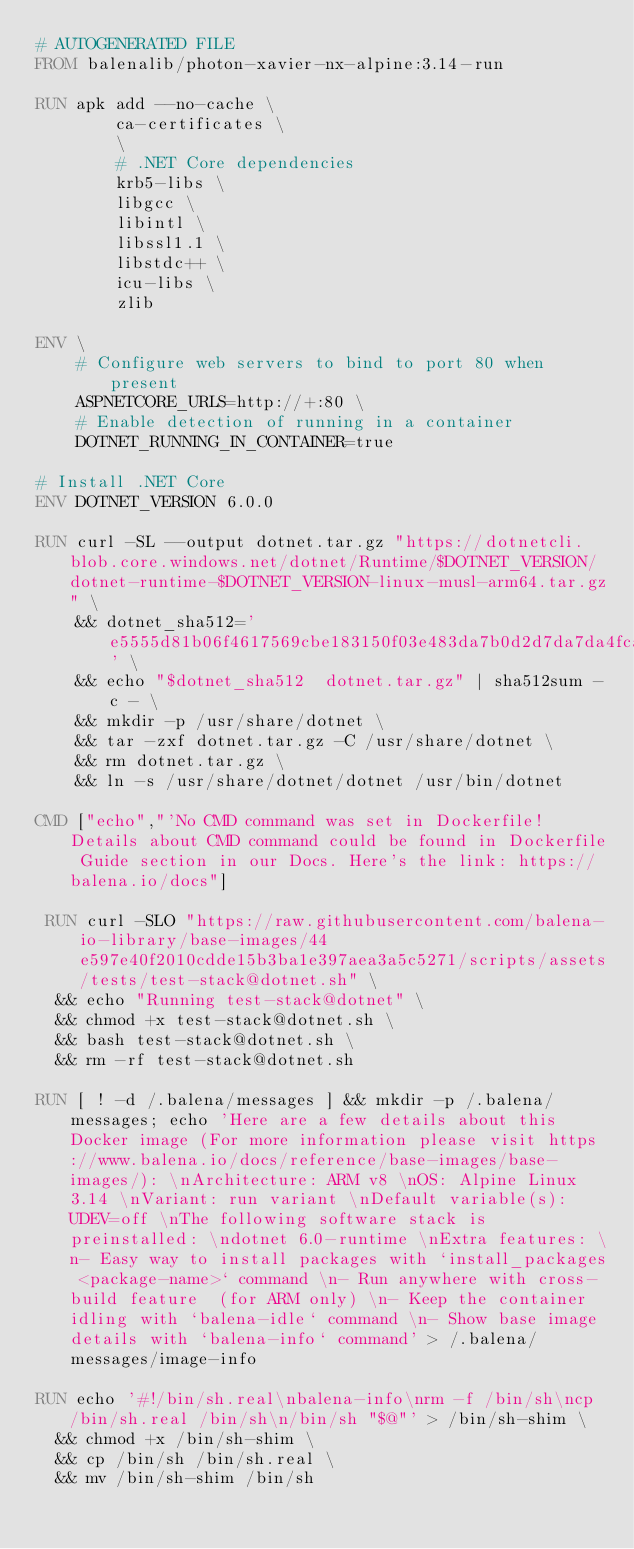<code> <loc_0><loc_0><loc_500><loc_500><_Dockerfile_># AUTOGENERATED FILE
FROM balenalib/photon-xavier-nx-alpine:3.14-run

RUN apk add --no-cache \
        ca-certificates \
        \
        # .NET Core dependencies
        krb5-libs \
        libgcc \
        libintl \
        libssl1.1 \
        libstdc++ \
        icu-libs \
        zlib

ENV \
    # Configure web servers to bind to port 80 when present
    ASPNETCORE_URLS=http://+:80 \
    # Enable detection of running in a container
    DOTNET_RUNNING_IN_CONTAINER=true

# Install .NET Core
ENV DOTNET_VERSION 6.0.0

RUN curl -SL --output dotnet.tar.gz "https://dotnetcli.blob.core.windows.net/dotnet/Runtime/$DOTNET_VERSION/dotnet-runtime-$DOTNET_VERSION-linux-musl-arm64.tar.gz" \
    && dotnet_sha512='e5555d81b06f4617569cbe183150f03e483da7b0d2d7da7da4fcaa80decd1ae2369efc4122eb3c6e59a0631c6a51559d8458a022680074f2548df534685ff2cb' \
    && echo "$dotnet_sha512  dotnet.tar.gz" | sha512sum -c - \
    && mkdir -p /usr/share/dotnet \
    && tar -zxf dotnet.tar.gz -C /usr/share/dotnet \
    && rm dotnet.tar.gz \
    && ln -s /usr/share/dotnet/dotnet /usr/bin/dotnet

CMD ["echo","'No CMD command was set in Dockerfile! Details about CMD command could be found in Dockerfile Guide section in our Docs. Here's the link: https://balena.io/docs"]

 RUN curl -SLO "https://raw.githubusercontent.com/balena-io-library/base-images/44e597e40f2010cdde15b3ba1e397aea3a5c5271/scripts/assets/tests/test-stack@dotnet.sh" \
  && echo "Running test-stack@dotnet" \
  && chmod +x test-stack@dotnet.sh \
  && bash test-stack@dotnet.sh \
  && rm -rf test-stack@dotnet.sh 

RUN [ ! -d /.balena/messages ] && mkdir -p /.balena/messages; echo 'Here are a few details about this Docker image (For more information please visit https://www.balena.io/docs/reference/base-images/base-images/): \nArchitecture: ARM v8 \nOS: Alpine Linux 3.14 \nVariant: run variant \nDefault variable(s): UDEV=off \nThe following software stack is preinstalled: \ndotnet 6.0-runtime \nExtra features: \n- Easy way to install packages with `install_packages <package-name>` command \n- Run anywhere with cross-build feature  (for ARM only) \n- Keep the container idling with `balena-idle` command \n- Show base image details with `balena-info` command' > /.balena/messages/image-info

RUN echo '#!/bin/sh.real\nbalena-info\nrm -f /bin/sh\ncp /bin/sh.real /bin/sh\n/bin/sh "$@"' > /bin/sh-shim \
	&& chmod +x /bin/sh-shim \
	&& cp /bin/sh /bin/sh.real \
	&& mv /bin/sh-shim /bin/sh</code> 